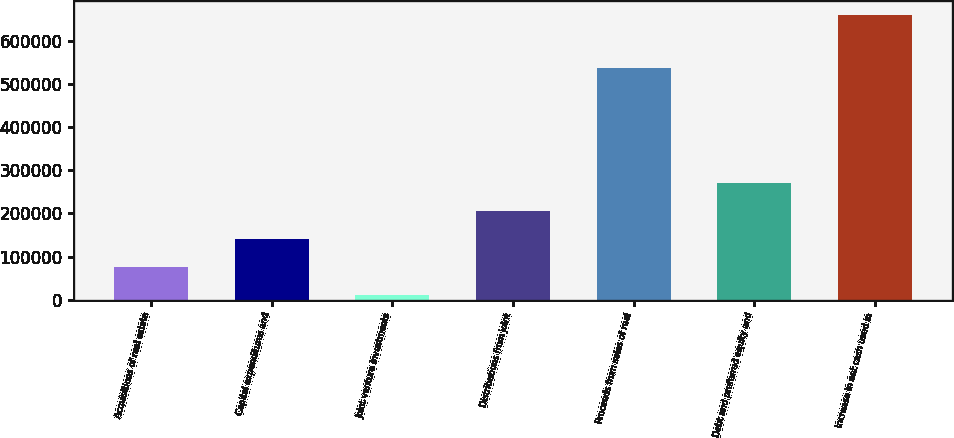Convert chart to OTSL. <chart><loc_0><loc_0><loc_500><loc_500><bar_chart><fcel>Acquisitions of real estate<fcel>Capital expenditures and<fcel>Joint venture investments<fcel>Distributions from joint<fcel>Proceeds from sales of real<fcel>Debt and preferred equity and<fcel>Increase in net cash used in<nl><fcel>76026.8<fcel>140874<fcel>11180<fcel>205720<fcel>538208<fcel>270567<fcel>659648<nl></chart> 